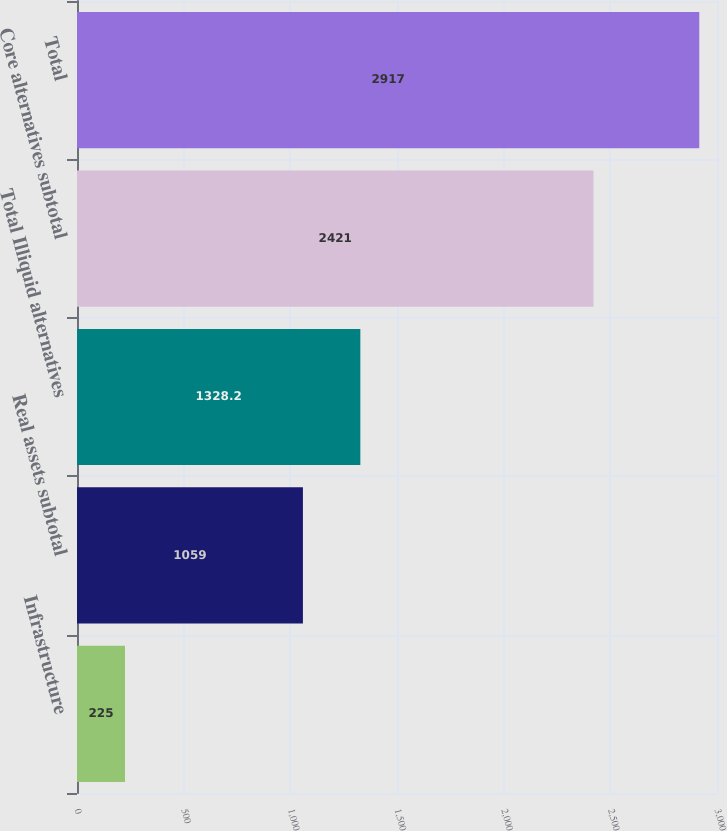Convert chart. <chart><loc_0><loc_0><loc_500><loc_500><bar_chart><fcel>Infrastructure<fcel>Real assets subtotal<fcel>Total Illiquid alternatives<fcel>Core alternatives subtotal<fcel>Total<nl><fcel>225<fcel>1059<fcel>1328.2<fcel>2421<fcel>2917<nl></chart> 